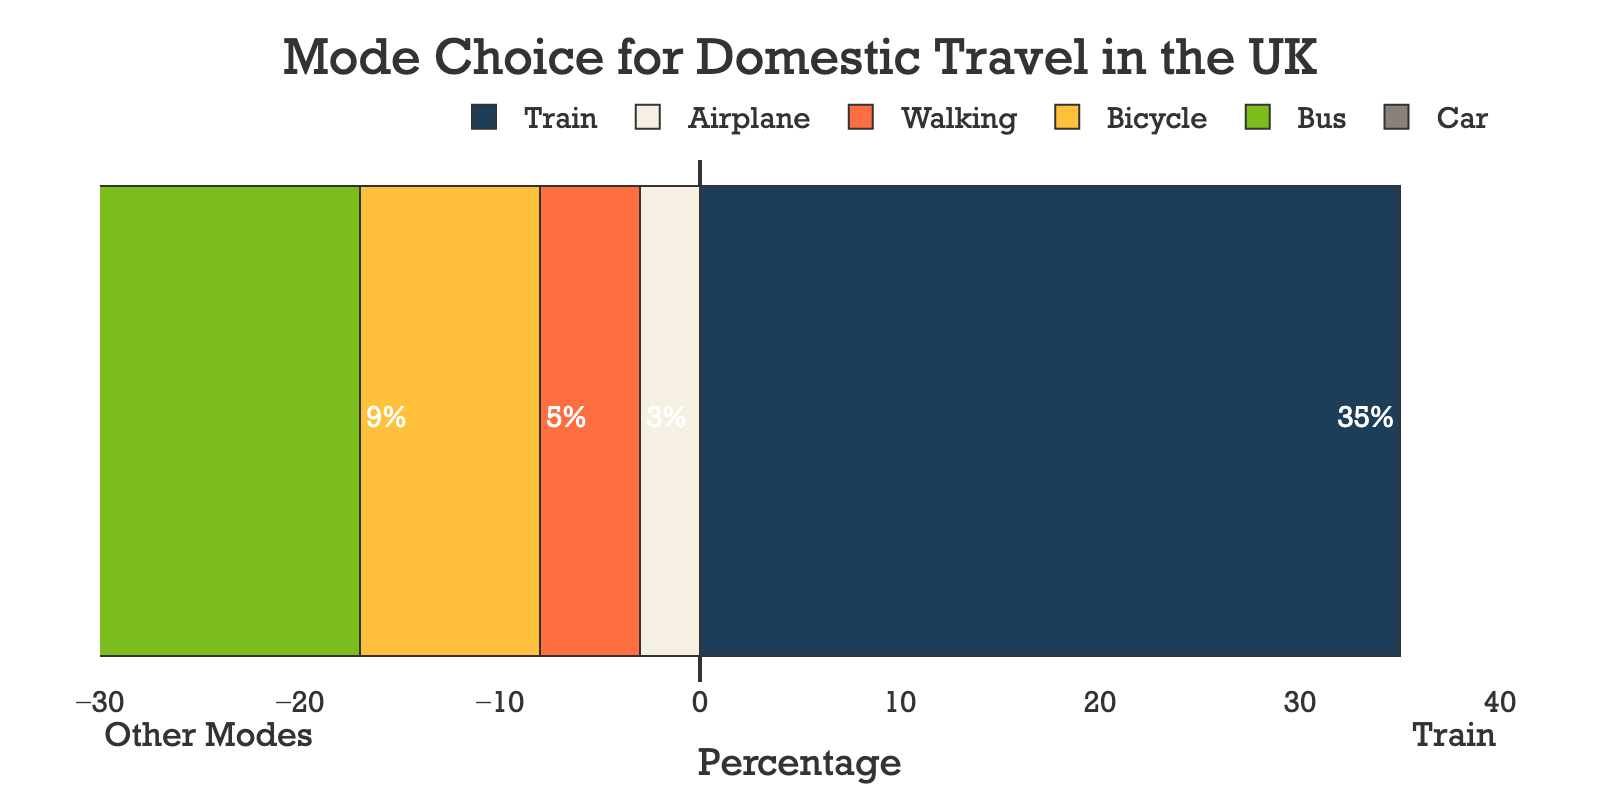What mode of transportation has the highest percentage for domestic travel in the UK? The bar for Train extends the furthest to the right, indicating it has the highest percentage.
Answer: Train Which mode of transport has the lowest percentage of usage for domestic travel? The smallest bar extending to the left represents Airplane.
Answer: Airplane How much higher is the percentage for Train compared to Car? The bar for Train shows 35%, and the bar for Car shows 28%, so 35% - 28% = 7%.
Answer: 7% What is the combined percentage for all modes of transportation other than Train? Adding the values for Car (28%), Bus (18%), Bicycle (9%), Walking (5%), and Airplane (3%) gives 28 + 18 + 9 + 5 + 3 = 63%.
Answer: 63% How does the percentage of Car compare to the percentage of Bus for domestic travel? The bar for Car representing 28% is longer than the bar for Bus representing 18%.
Answer: Car is higher Which mode of transportation has a percentage difference of 10% compared to Bicycle? The bar length difference between Bus (18%) and Bicycle (9%) is 18% - 9% = 9%. Check Walking, which shows 5%. The difference is 9% - 5% = 4%, not 10%. Checking Car next, 28% - 9% = 19%, not 10%. Finally, Train is 35%, with 35% - 9% = 26%, not 10%. No other mode fits exactly.
Answer: None What is the average percentage for Car, Bicycle, and Walking? Summing up the values for Car (28%), Bicycle (9%), and Walking (5%) and dividing by 3 gives (28 + 9 + 5) / 3 = 42 / 3 = 14%.
Answer: 14% Which transport mode has a percentage closer to the midpoint of the range shown on the x-axis? The x-axis ranges from -30% to +40%, the midpoint is (40 - 30) / 2 = 5%. The percentage closest to 5% is Walking with 5%.
Answer: Walking How does the visual length of the bars for Train and Airplane compare? The bar for Train is significantly longer and extends positively to the right, while Airplane's bar is quite short and extends to the left.
Answer: Train's bar is much longer What is the cumulative positive percentage represented in the chart? Only Train has a positive percentage of 35%.
Answer: 35% 